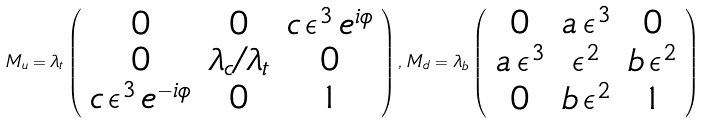<formula> <loc_0><loc_0><loc_500><loc_500>M _ { u } = \lambda _ { t } \left ( \begin{array} { c c c } 0 & 0 & c \, \epsilon ^ { 3 } \, e ^ { i \phi } \\ 0 & \lambda _ { c } / \lambda _ { t } & 0 \\ c \, \epsilon ^ { 3 } \, e ^ { - i \phi } & 0 & 1 \end{array} \right ) , \, M _ { d } = \lambda _ { b } \left ( \begin{array} { c c c } 0 & a \, \epsilon ^ { 3 } & 0 \\ a \, \epsilon ^ { 3 } & \epsilon ^ { 2 } & b \, \epsilon ^ { 2 } \\ 0 & b \, \epsilon ^ { 2 } & 1 \end{array} \right )</formula> 